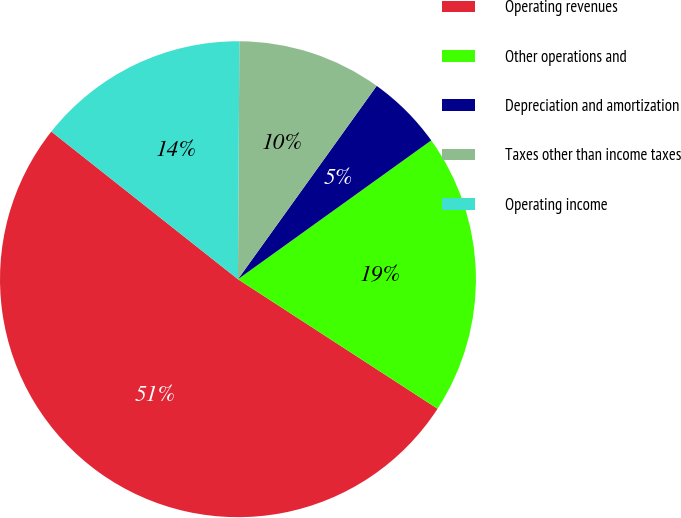<chart> <loc_0><loc_0><loc_500><loc_500><pie_chart><fcel>Operating revenues<fcel>Other operations and<fcel>Depreciation and amortization<fcel>Taxes other than income taxes<fcel>Operating income<nl><fcel>51.48%<fcel>19.07%<fcel>5.18%<fcel>9.81%<fcel>14.44%<nl></chart> 